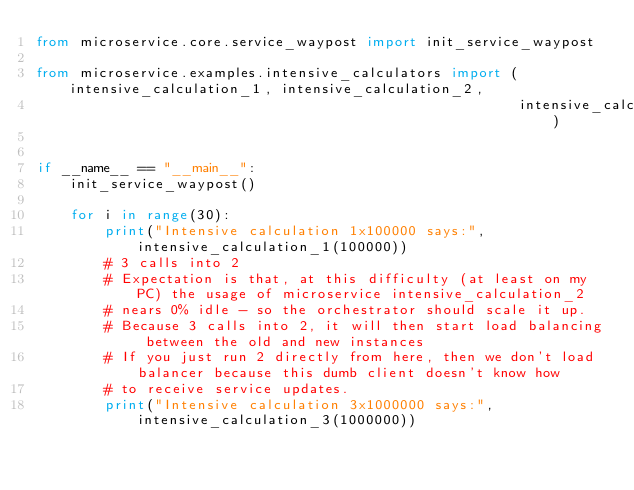Convert code to text. <code><loc_0><loc_0><loc_500><loc_500><_Python_>from microservice.core.service_waypost import init_service_waypost

from microservice.examples.intensive_calculators import (intensive_calculation_1, intensive_calculation_2,
                                                         intensive_calculation_3)


if __name__ == "__main__":
    init_service_waypost()

    for i in range(30):
        print("Intensive calculation 1x100000 says:", intensive_calculation_1(100000))
        # 3 calls into 2
        # Expectation is that, at this difficulty (at least on my PC) the usage of microservice intensive_calculation_2
        # nears 0% idle - so the orchestrator should scale it up.
        # Because 3 calls into 2, it will then start load balancing between the old and new instances
        # If you just run 2 directly from here, then we don't load balancer because this dumb client doesn't know how
        # to receive service updates.
        print("Intensive calculation 3x1000000 says:", intensive_calculation_3(1000000))
</code> 